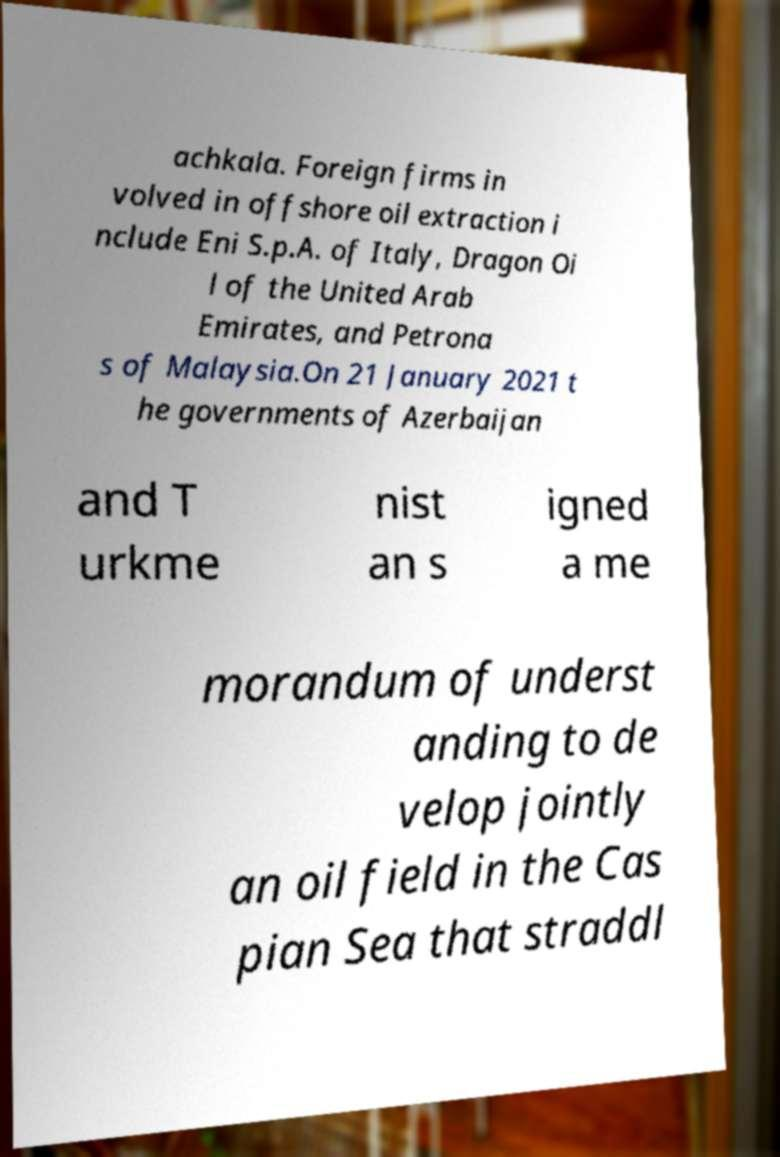For documentation purposes, I need the text within this image transcribed. Could you provide that? achkala. Foreign firms in volved in offshore oil extraction i nclude Eni S.p.A. of Italy, Dragon Oi l of the United Arab Emirates, and Petrona s of Malaysia.On 21 January 2021 t he governments of Azerbaijan and T urkme nist an s igned a me morandum of underst anding to de velop jointly an oil field in the Cas pian Sea that straddl 